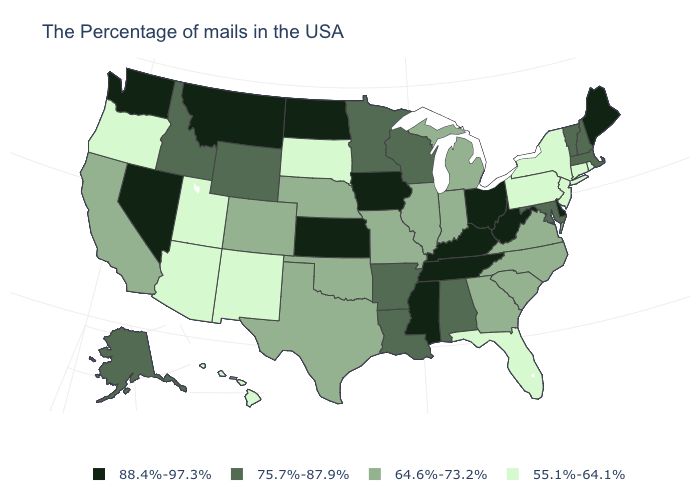Among the states that border Wyoming , which have the lowest value?
Quick response, please. South Dakota, Utah. What is the value of New Hampshire?
Short answer required. 75.7%-87.9%. Does the map have missing data?
Keep it brief. No. Does Wisconsin have the highest value in the MidWest?
Write a very short answer. No. Name the states that have a value in the range 88.4%-97.3%?
Quick response, please. Maine, Delaware, West Virginia, Ohio, Kentucky, Tennessee, Mississippi, Iowa, Kansas, North Dakota, Montana, Nevada, Washington. Does Oklahoma have a lower value than Wisconsin?
Quick response, please. Yes. Name the states that have a value in the range 64.6%-73.2%?
Keep it brief. Virginia, North Carolina, South Carolina, Georgia, Michigan, Indiana, Illinois, Missouri, Nebraska, Oklahoma, Texas, Colorado, California. Name the states that have a value in the range 55.1%-64.1%?
Be succinct. Rhode Island, Connecticut, New York, New Jersey, Pennsylvania, Florida, South Dakota, New Mexico, Utah, Arizona, Oregon, Hawaii. Does the map have missing data?
Quick response, please. No. What is the lowest value in states that border Washington?
Write a very short answer. 55.1%-64.1%. What is the value of Tennessee?
Quick response, please. 88.4%-97.3%. What is the value of Vermont?
Answer briefly. 75.7%-87.9%. Name the states that have a value in the range 75.7%-87.9%?
Give a very brief answer. Massachusetts, New Hampshire, Vermont, Maryland, Alabama, Wisconsin, Louisiana, Arkansas, Minnesota, Wyoming, Idaho, Alaska. What is the lowest value in the Northeast?
Write a very short answer. 55.1%-64.1%. Name the states that have a value in the range 75.7%-87.9%?
Quick response, please. Massachusetts, New Hampshire, Vermont, Maryland, Alabama, Wisconsin, Louisiana, Arkansas, Minnesota, Wyoming, Idaho, Alaska. 